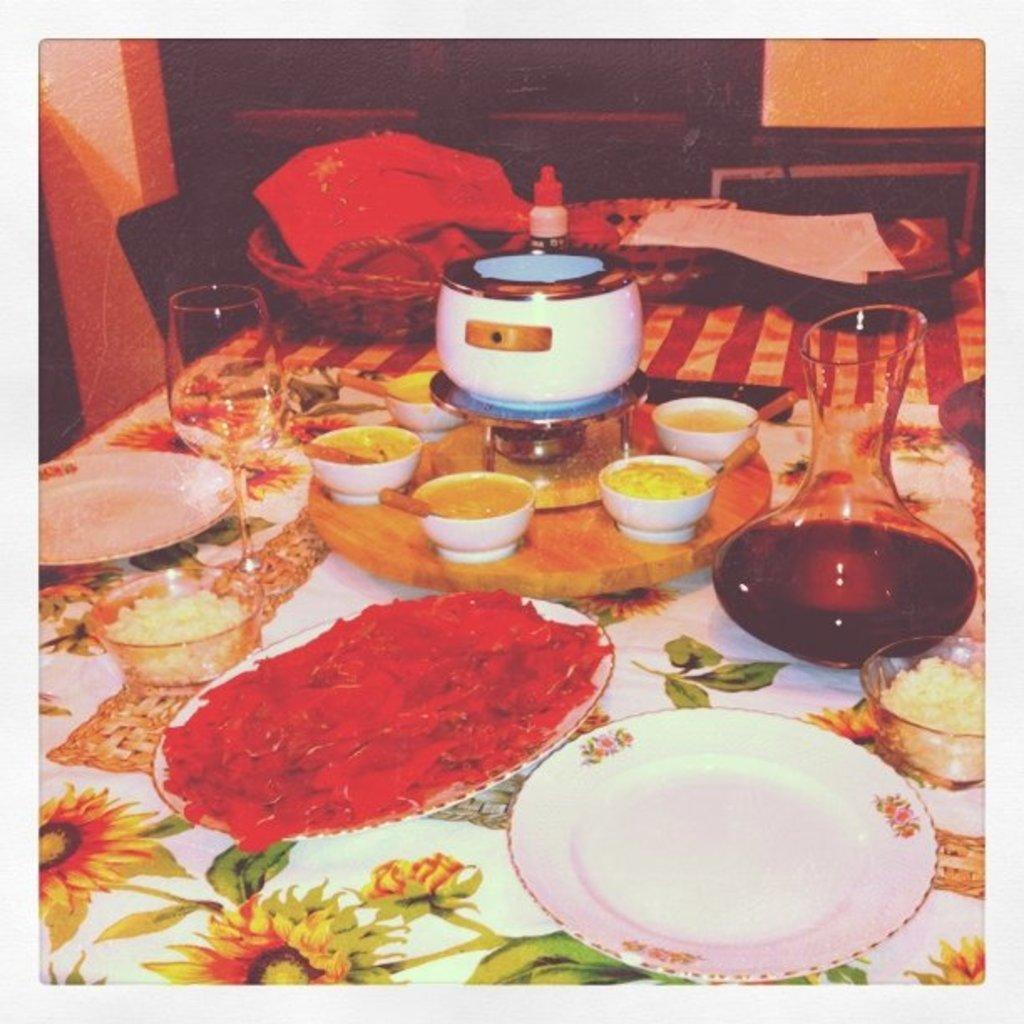What type of food items can be seen in the image? There are food items in bowls and on a plate in the image. How are the food items arranged in the image? The food items are arranged on trays, in bowls, and on a plate in the image. What type of container is present in the image? There is a jug in the image. What type of drinking vessel is present in the image? There is a glass in the image. Where are the food items and containers located? They are on a table in the image. What can be seen in the background of the image? There is a chair in the background of the image. What type of lace is draped over the food items in the image? There is no lace present in the image; it is a collection of food items, trays, a jug, a glass, and a table. 